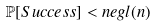Convert formula to latex. <formula><loc_0><loc_0><loc_500><loc_500>\mathbb { P } [ S u c c e s s ] < n e g l ( n )</formula> 